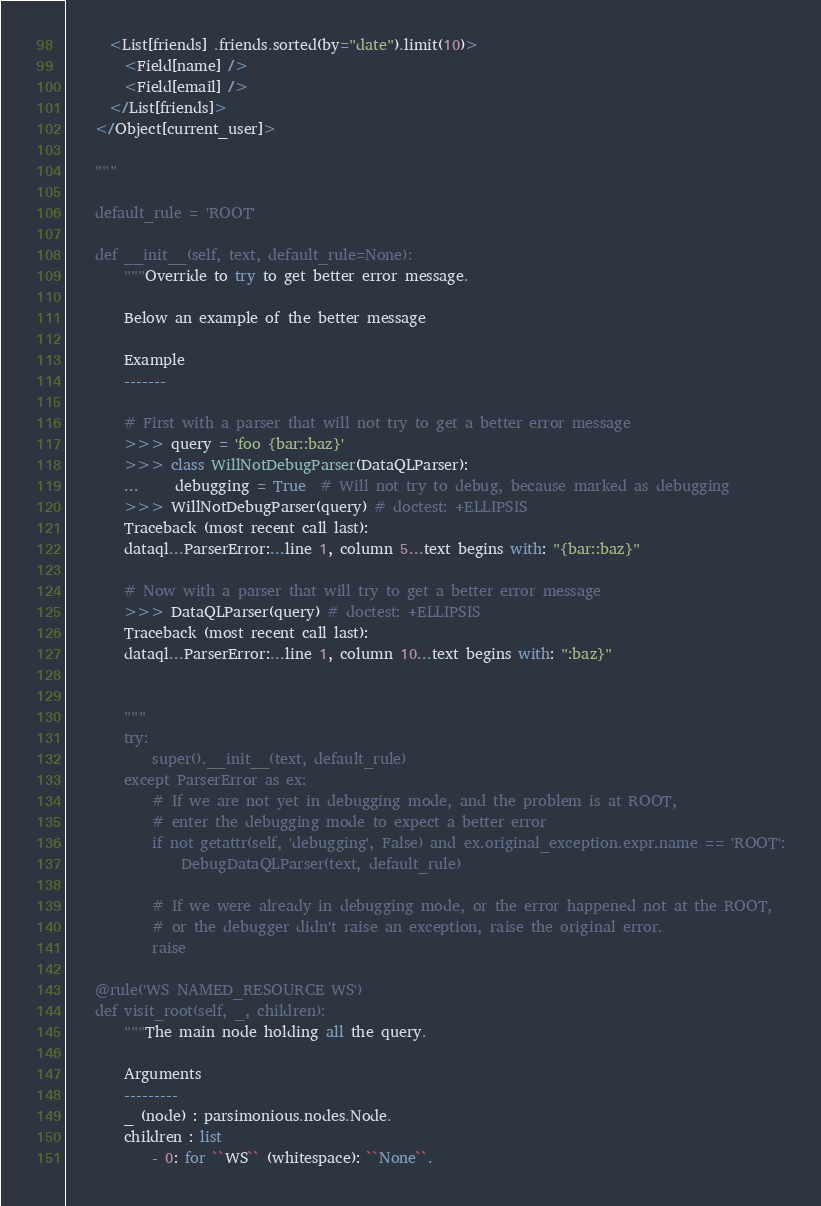Convert code to text. <code><loc_0><loc_0><loc_500><loc_500><_Python_>      <List[friends] .friends.sorted(by="date").limit(10)>
        <Field[name] />
        <Field[email] />
      </List[friends]>
    </Object[current_user]>

    """

    default_rule = 'ROOT'

    def __init__(self, text, default_rule=None):
        """Override to try to get better error message.

        Below an example of the better message

        Example
        -------

        # First with a parser that will not try to get a better error message
        >>> query = 'foo {bar::baz}'
        >>> class WillNotDebugParser(DataQLParser):
        ...     debugging = True  # Will not try to debug, because marked as debugging
        >>> WillNotDebugParser(query) # doctest: +ELLIPSIS
        Traceback (most recent call last):
        dataql...ParserError:...line 1, column 5...text begins with: "{bar::baz}"

        # Now with a parser that will try to get a better error message
        >>> DataQLParser(query) # doctest: +ELLIPSIS
        Traceback (most recent call last):
        dataql...ParserError:...line 1, column 10...text begins with: ":baz}"


        """
        try:
            super().__init__(text, default_rule)
        except ParserError as ex:
            # If we are not yet in debugging mode, and the problem is at ROOT,
            # enter the debugging mode to expect a better error
            if not getattr(self, 'debugging', False) and ex.original_exception.expr.name == 'ROOT':
                DebugDataQLParser(text, default_rule)

            # If we were already in debugging mode, or the error happened not at the ROOT,
            # or the debugger didn't raise an exception, raise the original error.
            raise

    @rule('WS NAMED_RESOURCE WS')
    def visit_root(self, _, children):
        """The main node holding all the query.

        Arguments
        ---------
        _ (node) : parsimonious.nodes.Node.
        children : list
            - 0: for ``WS`` (whitespace): ``None``.</code> 